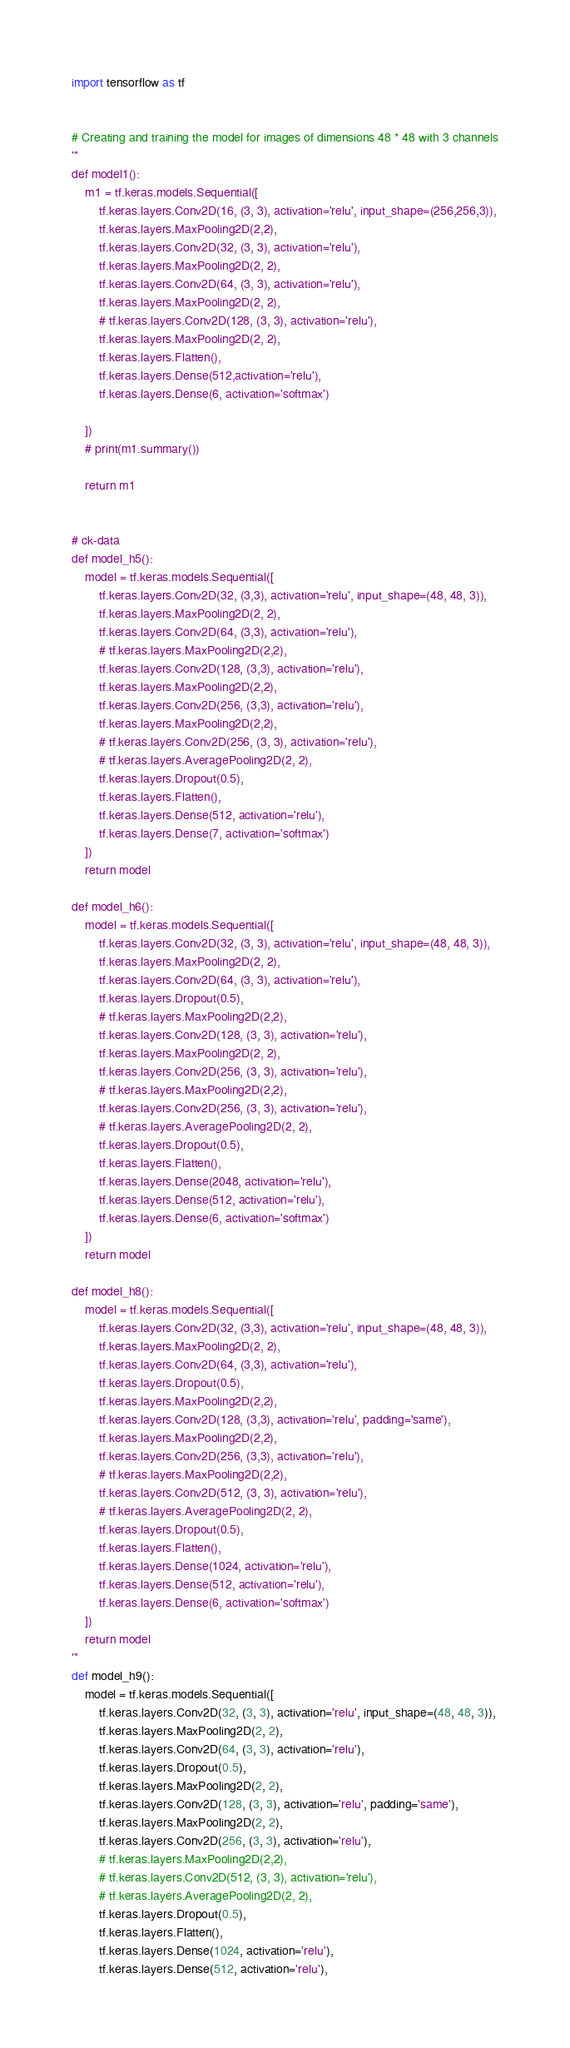<code> <loc_0><loc_0><loc_500><loc_500><_Python_>import tensorflow as tf


# Creating and training the model for images of dimensions 48 * 48 with 3 channels
'''
def model1():
    m1 = tf.keras.models.Sequential([
        tf.keras.layers.Conv2D(16, (3, 3), activation='relu', input_shape=(256,256,3)),
        tf.keras.layers.MaxPooling2D(2,2),
        tf.keras.layers.Conv2D(32, (3, 3), activation='relu'),
        tf.keras.layers.MaxPooling2D(2, 2),
        tf.keras.layers.Conv2D(64, (3, 3), activation='relu'),
        tf.keras.layers.MaxPooling2D(2, 2),
        # tf.keras.layers.Conv2D(128, (3, 3), activation='relu'),
        tf.keras.layers.MaxPooling2D(2, 2),
        tf.keras.layers.Flatten(),
        tf.keras.layers.Dense(512,activation='relu'),
        tf.keras.layers.Dense(6, activation='softmax')

    ])
    # print(m1.summary())

    return m1


# ck-data
def model_h5():
    model = tf.keras.models.Sequential([
        tf.keras.layers.Conv2D(32, (3,3), activation='relu', input_shape=(48, 48, 3)),
        tf.keras.layers.MaxPooling2D(2, 2),
        tf.keras.layers.Conv2D(64, (3,3), activation='relu'),
        # tf.keras.layers.MaxPooling2D(2,2),
        tf.keras.layers.Conv2D(128, (3,3), activation='relu'),
        tf.keras.layers.MaxPooling2D(2,2),
        tf.keras.layers.Conv2D(256, (3,3), activation='relu'),
        tf.keras.layers.MaxPooling2D(2,2),
        # tf.keras.layers.Conv2D(256, (3, 3), activation='relu'),
        # tf.keras.layers.AveragePooling2D(2, 2),
        tf.keras.layers.Dropout(0.5),
        tf.keras.layers.Flatten(),
        tf.keras.layers.Dense(512, activation='relu'),
        tf.keras.layers.Dense(7, activation='softmax')
    ])
    return model

def model_h6():
    model = tf.keras.models.Sequential([
        tf.keras.layers.Conv2D(32, (3, 3), activation='relu', input_shape=(48, 48, 3)),
        tf.keras.layers.MaxPooling2D(2, 2),
        tf.keras.layers.Conv2D(64, (3, 3), activation='relu'),
        tf.keras.layers.Dropout(0.5),
        # tf.keras.layers.MaxPooling2D(2,2),
        tf.keras.layers.Conv2D(128, (3, 3), activation='relu'),
        tf.keras.layers.MaxPooling2D(2, 2),
        tf.keras.layers.Conv2D(256, (3, 3), activation='relu'),
        # tf.keras.layers.MaxPooling2D(2,2),
        tf.keras.layers.Conv2D(256, (3, 3), activation='relu'),
        # tf.keras.layers.AveragePooling2D(2, 2),
        tf.keras.layers.Dropout(0.5),
        tf.keras.layers.Flatten(),
        tf.keras.layers.Dense(2048, activation='relu'),
        tf.keras.layers.Dense(512, activation='relu'),
        tf.keras.layers.Dense(6, activation='softmax')
    ])
    return model

def model_h8():
    model = tf.keras.models.Sequential([
        tf.keras.layers.Conv2D(32, (3,3), activation='relu', input_shape=(48, 48, 3)),
        tf.keras.layers.MaxPooling2D(2, 2),
        tf.keras.layers.Conv2D(64, (3,3), activation='relu'),
        tf.keras.layers.Dropout(0.5),
        tf.keras.layers.MaxPooling2D(2,2),
        tf.keras.layers.Conv2D(128, (3,3), activation='relu', padding='same'),
        tf.keras.layers.MaxPooling2D(2,2),
        tf.keras.layers.Conv2D(256, (3,3), activation='relu'),
        # tf.keras.layers.MaxPooling2D(2,2),
        tf.keras.layers.Conv2D(512, (3, 3), activation='relu'),
        # tf.keras.layers.AveragePooling2D(2, 2),
        tf.keras.layers.Dropout(0.5),
        tf.keras.layers.Flatten(),
        tf.keras.layers.Dense(1024, activation='relu'),
        tf.keras.layers.Dense(512, activation='relu'),
        tf.keras.layers.Dense(6, activation='softmax')
    ])
    return model
'''
def model_h9():
    model = tf.keras.models.Sequential([
        tf.keras.layers.Conv2D(32, (3, 3), activation='relu', input_shape=(48, 48, 3)),
        tf.keras.layers.MaxPooling2D(2, 2),
        tf.keras.layers.Conv2D(64, (3, 3), activation='relu'),
        tf.keras.layers.Dropout(0.5),
        tf.keras.layers.MaxPooling2D(2, 2),
        tf.keras.layers.Conv2D(128, (3, 3), activation='relu', padding='same'),
        tf.keras.layers.MaxPooling2D(2, 2),
        tf.keras.layers.Conv2D(256, (3, 3), activation='relu'),
        # tf.keras.layers.MaxPooling2D(2,2),
        # tf.keras.layers.Conv2D(512, (3, 3), activation='relu'),
        # tf.keras.layers.AveragePooling2D(2, 2),
        tf.keras.layers.Dropout(0.5),
        tf.keras.layers.Flatten(),
        tf.keras.layers.Dense(1024, activation='relu'),
        tf.keras.layers.Dense(512, activation='relu'),</code> 